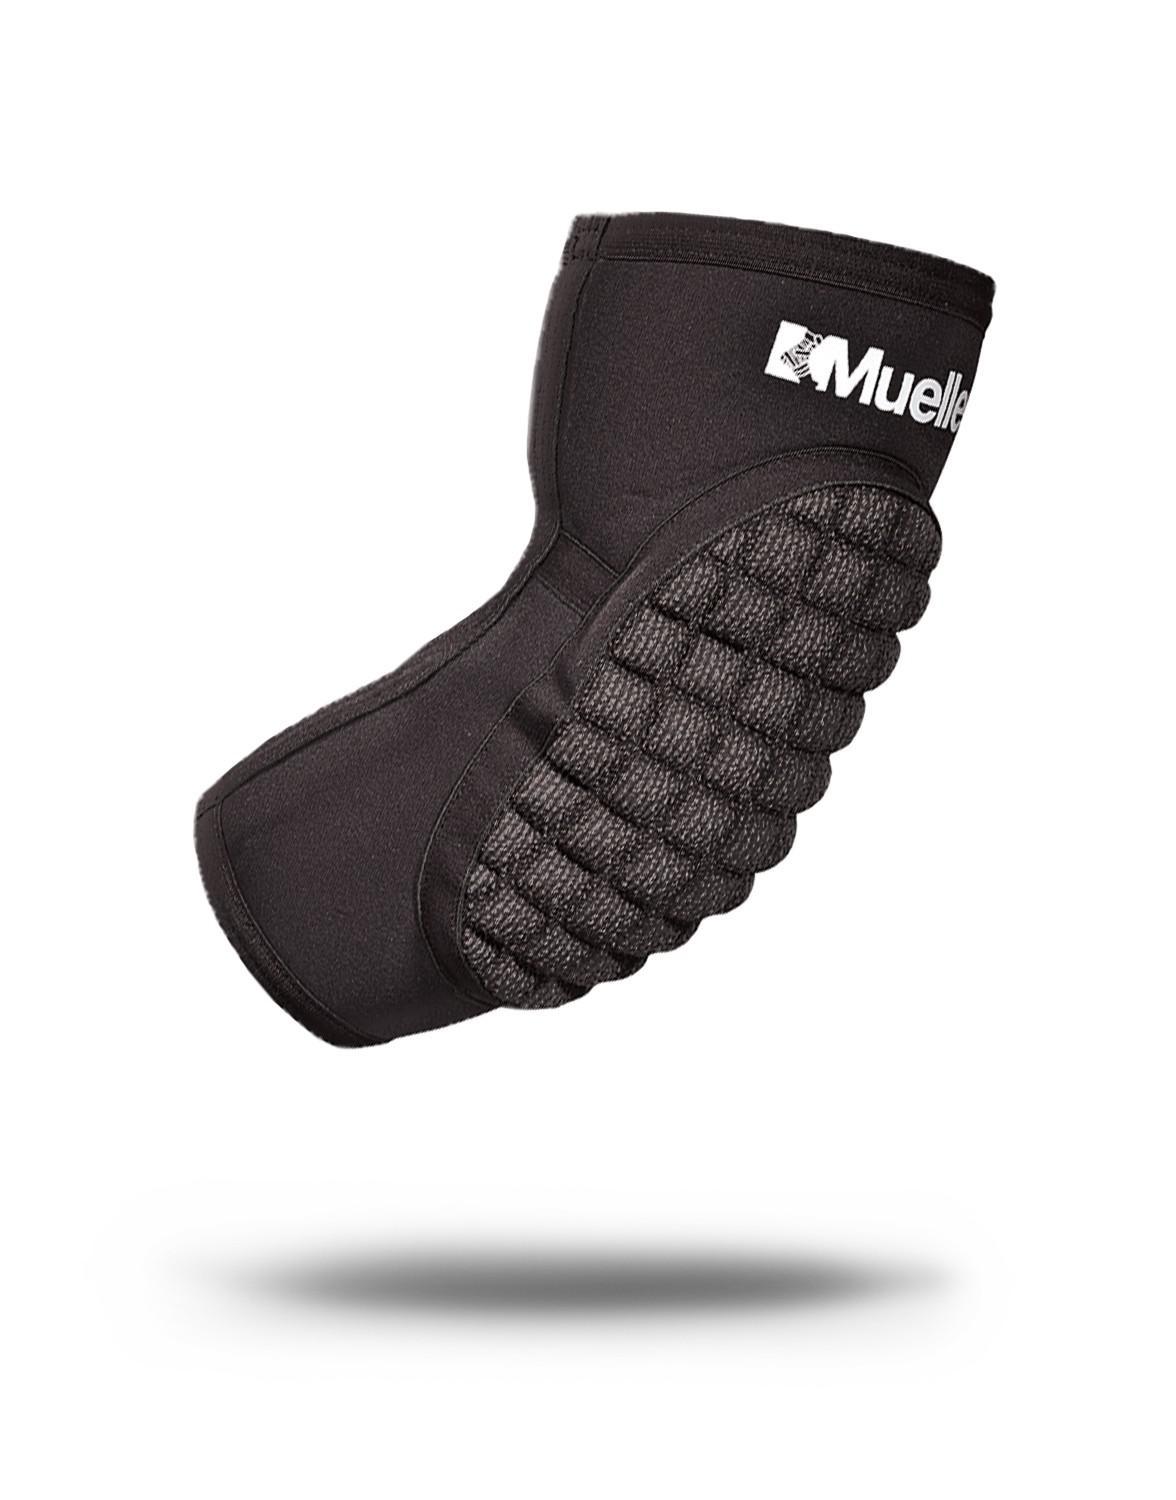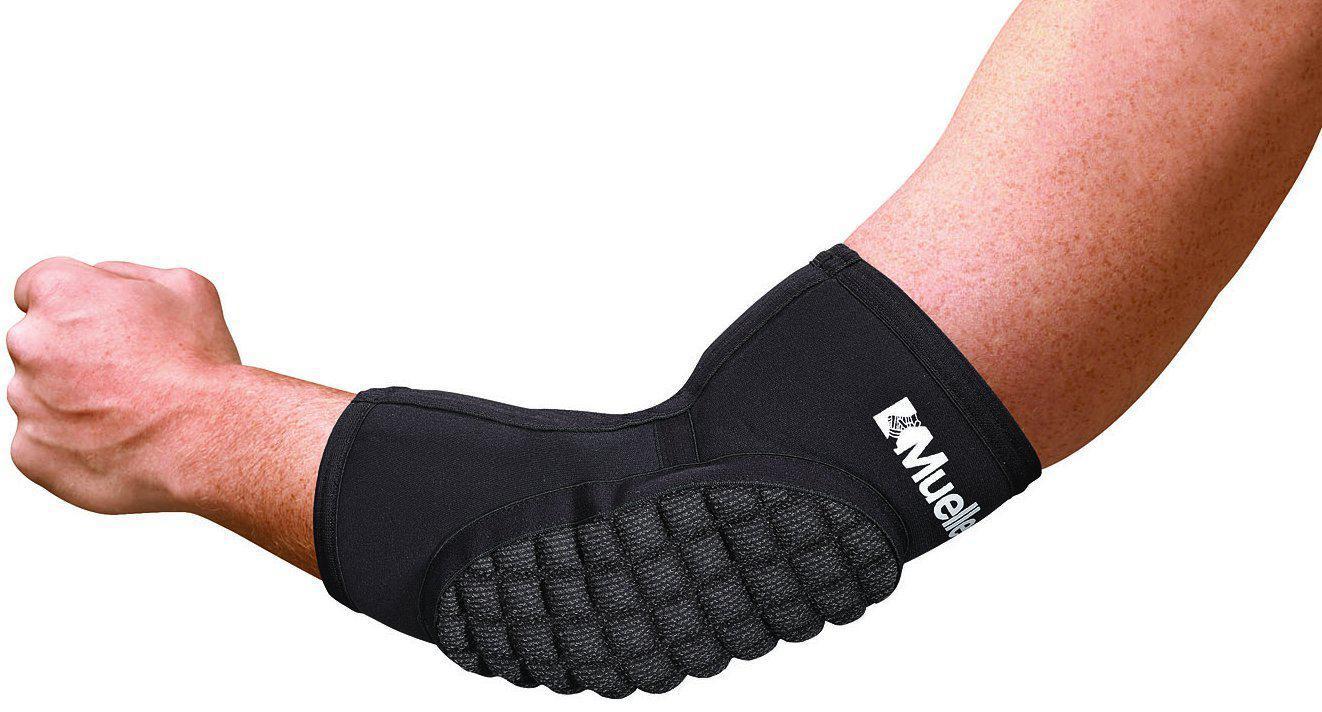The first image is the image on the left, the second image is the image on the right. Assess this claim about the two images: "The pads are demonstrated on at least one leg.". Correct or not? Answer yes or no. No. 